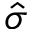<formula> <loc_0><loc_0><loc_500><loc_500>\hat { \sigma }</formula> 